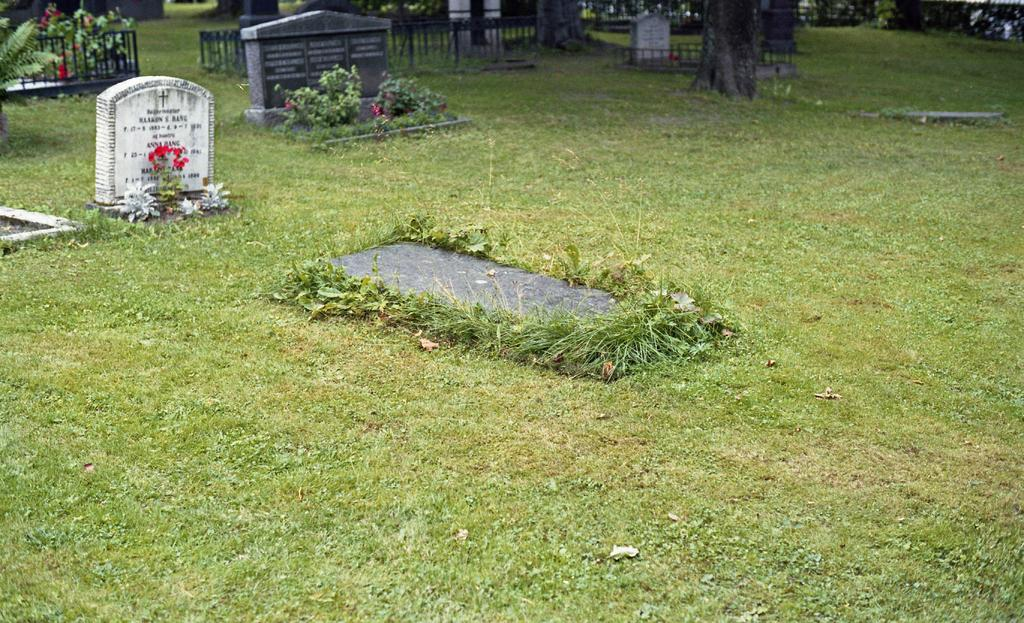What can be seen on the grass in the image? There are graves on the grass in the image. What is visible in the background of the image? There are plants, fences, and trees in the background of the image. What type of cork can be seen on the desk in the image? There is no desk or cork present in the image; it features graves on the grass and various elements in the background. 